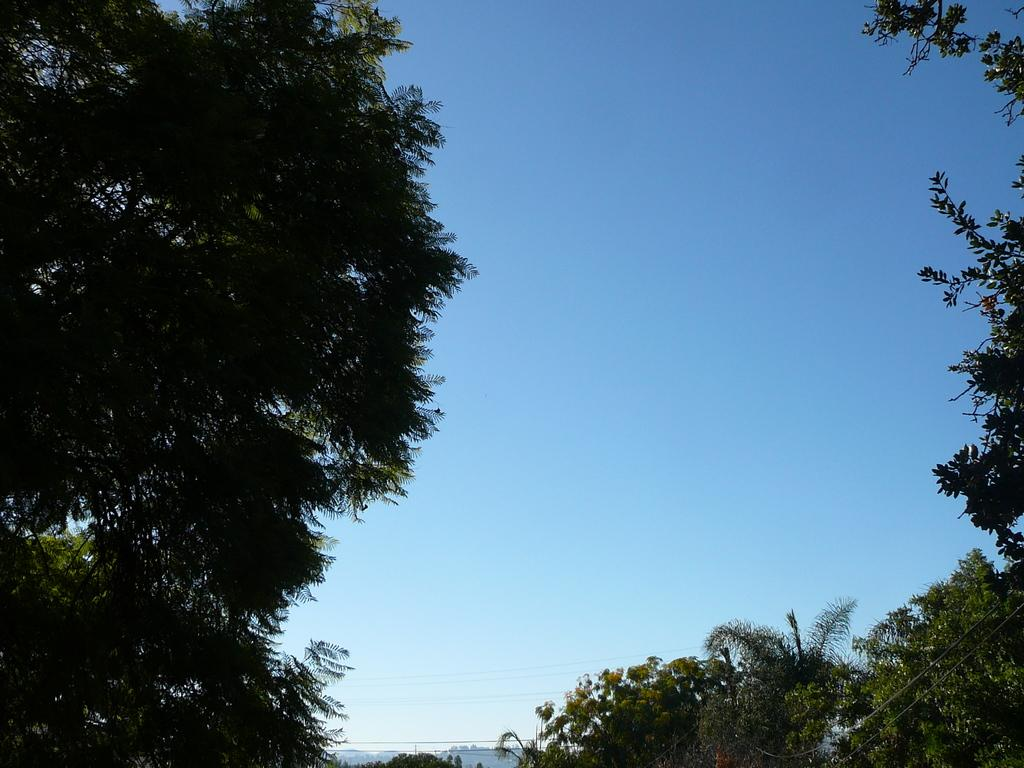What can be seen at the bottom of the image? There are wires, poles, and hills at the bottom of the image. What type of vegetation is visible in the background of the image? There are trees in the background of the image. What is visible at the top of the image? The sky is visible at the top of the image. What color is the shirt worn by the tree in the image? There is no shirt or person wearing a shirt in the image, as it features trees and other natural elements. What year is depicted in the image? The image does not depict a specific year; it is a snapshot of a natural scene. 